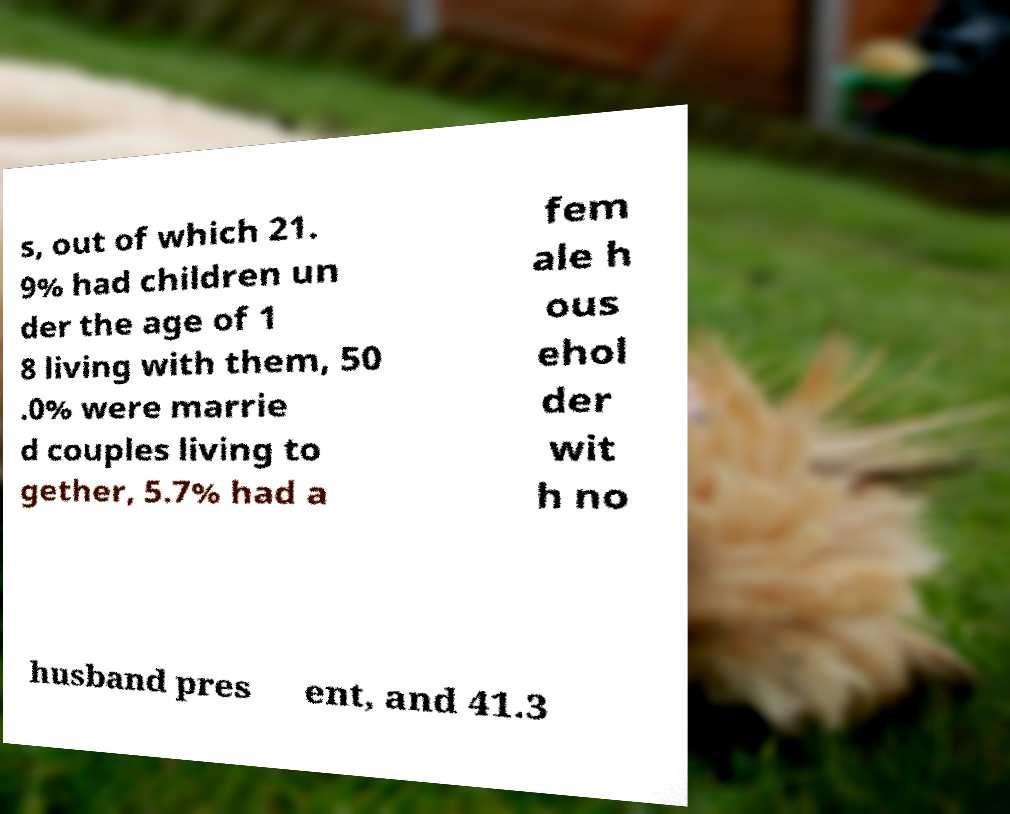Please read and relay the text visible in this image. What does it say? s, out of which 21. 9% had children un der the age of 1 8 living with them, 50 .0% were marrie d couples living to gether, 5.7% had a fem ale h ous ehol der wit h no husband pres ent, and 41.3 